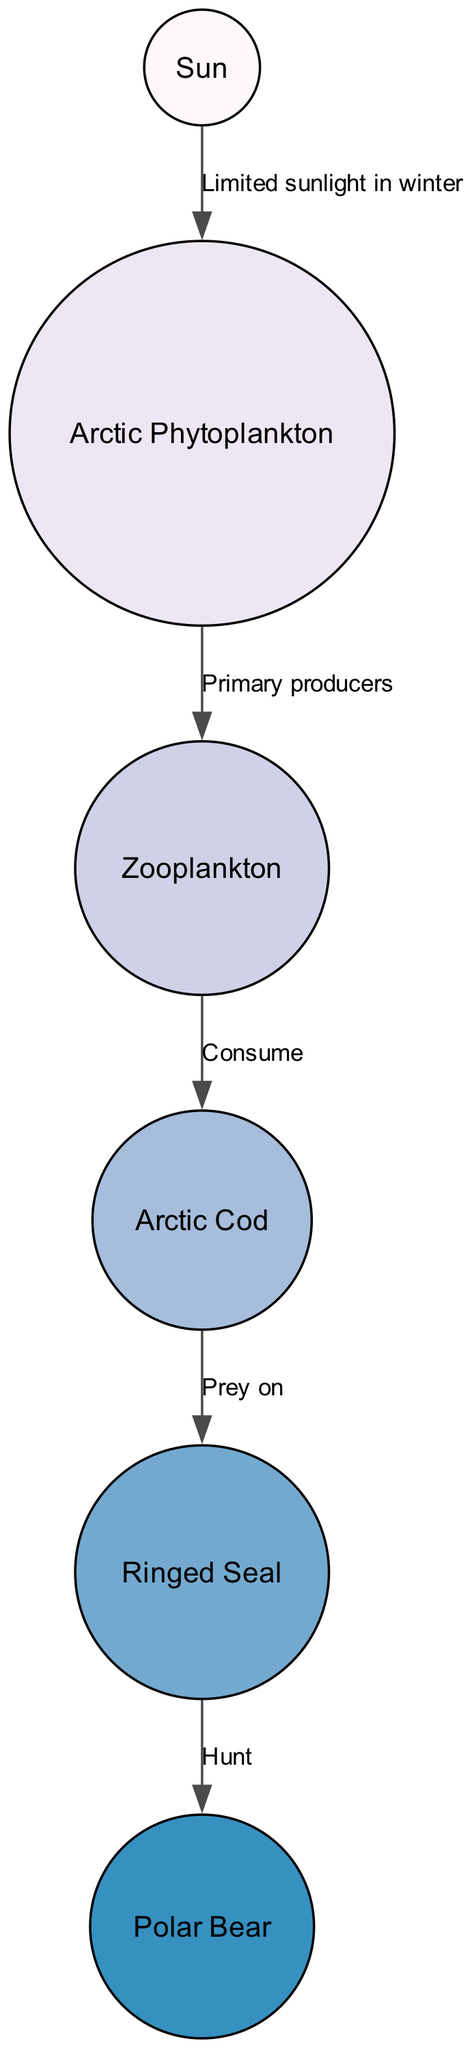What is the primary producer in the Arctic food chain? By analyzing the diagram, we see that Arctic phytoplankton is the starting point for energy transfer in this food chain, clearly labeled as the primary producer.
Answer: Arctic Phytoplankton How many nodes are there in the diagram? The diagram consists of six distinct nodes: Sun, Arctic Phytoplankton, Zooplankton, Arctic Cod, Ringed Seal, and Polar Bear. Counting these reveals that there are six nodes in total.
Answer: 6 What is the relationship between phytoplankton and zooplankton? The diagram shows an edge pointing from phytoplankton to zooplankton, labeled "Primary producers," indicating that phytoplankton serve as the food source for zooplankton.
Answer: Primary producers Who is at the top of the food chain? A careful look at the diagram indicates that the Polar Bear is the final node connected on the top line, making it the apex predator in this food chain.
Answer: Polar Bear How many edges are present in the diagram? By counting the connections (edges) between nodes in the diagram, we find there are five edges connecting the nodes, detailing the flow of energy through the food chain.
Answer: 5 What role does the seal play in this food chain? The diagram shows that seals prey on Arctic Cod, which clearly indicates their role as a consumer or predator in the marine food web.
Answer: Prey on What limits sunlight exposure during winter? The diagram indicates that limited sunlight in winter is an important factor affecting the flow of energy in the food chain, leading to a vital relationship between sunlight and phytoplankton.
Answer: Limited sunlight in winter Which organism is directly consumed by the fish? Observing the edge from zooplankton to fish labeled "Consume," we can conclude that zooplankton is the organism directly preyed upon by Arctic Cod.
Answer: Zooplankton What is the flow direction between the seal and the polar bear? The diagram shows a directed edge from seal to polar bear, indicating that seals are hunted as prey by polar bears, thus representing a predator-prey relationship.
Answer: Hunt 